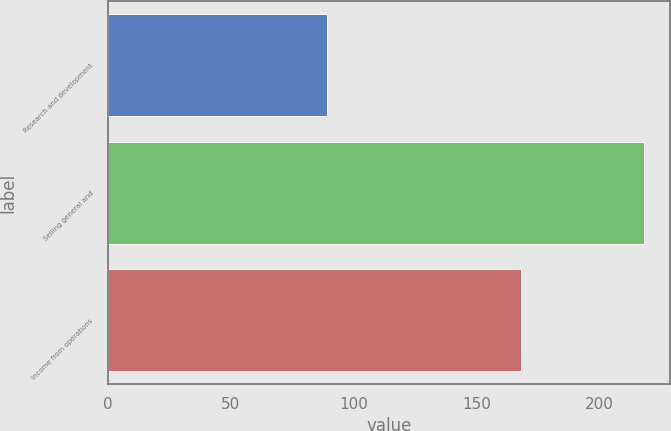Convert chart. <chart><loc_0><loc_0><loc_500><loc_500><bar_chart><fcel>Research and development<fcel>Selling general and<fcel>Income from operations<nl><fcel>89<fcel>218<fcel>168<nl></chart> 